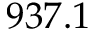<formula> <loc_0><loc_0><loc_500><loc_500>9 3 7 . 1</formula> 